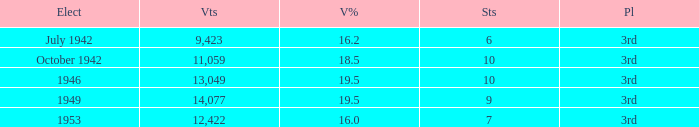Name the total number of seats for votes % more than 19.5 0.0. 